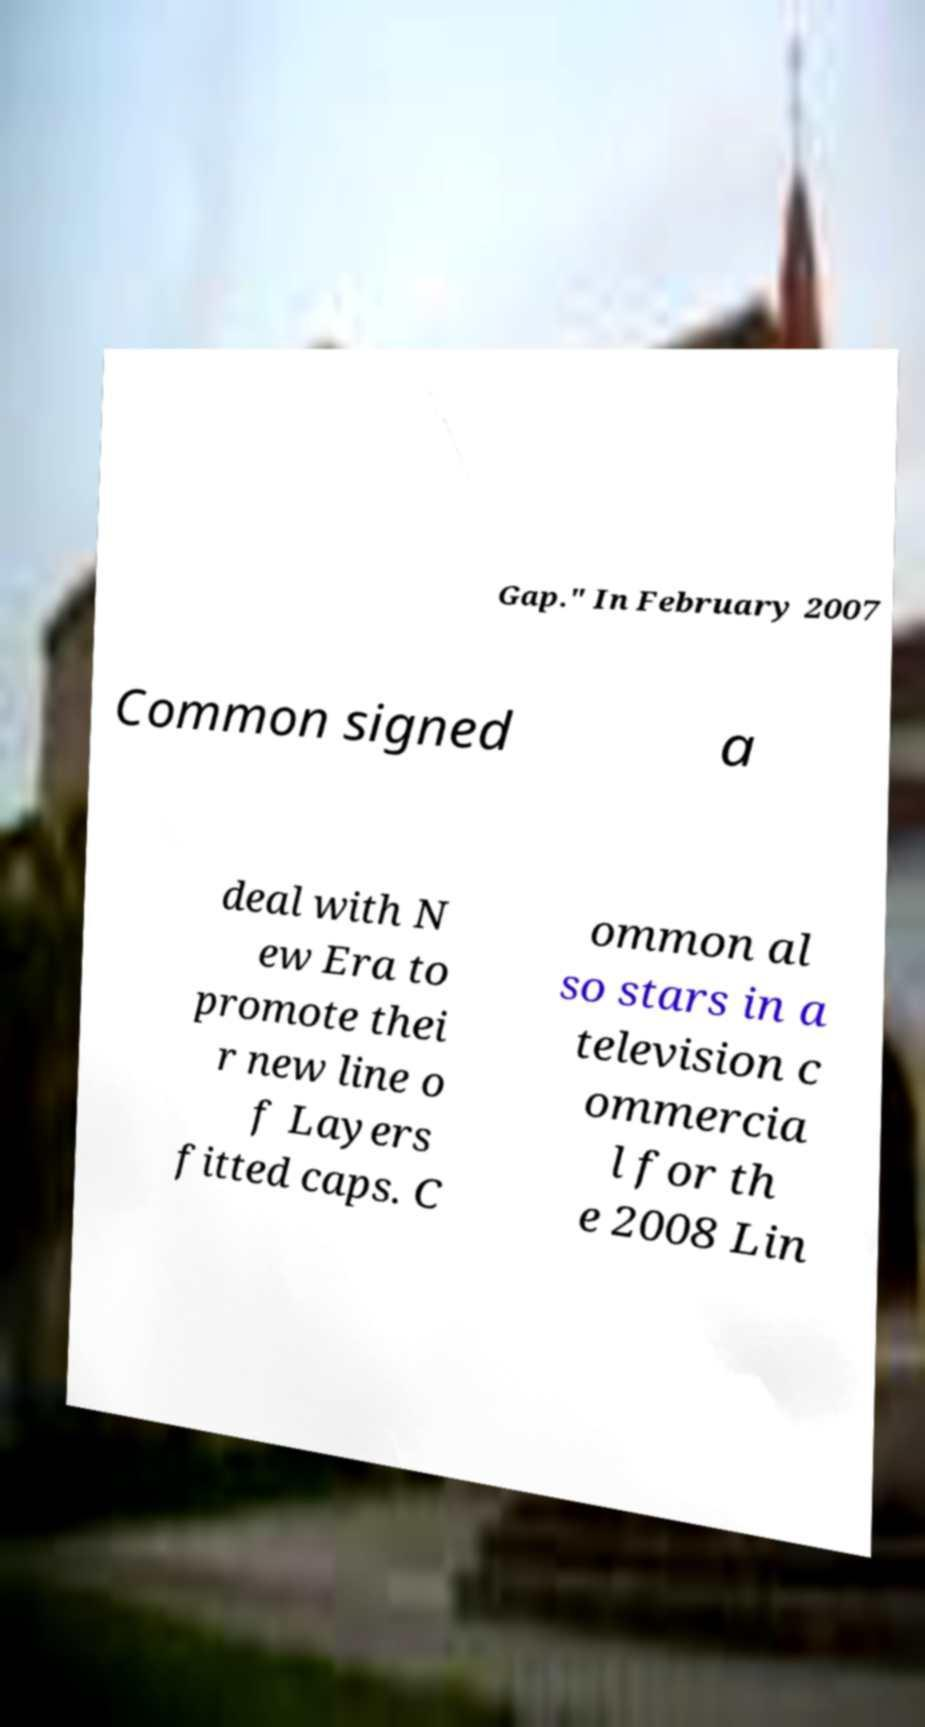Can you read and provide the text displayed in the image?This photo seems to have some interesting text. Can you extract and type it out for me? Gap." In February 2007 Common signed a deal with N ew Era to promote thei r new line o f Layers fitted caps. C ommon al so stars in a television c ommercia l for th e 2008 Lin 